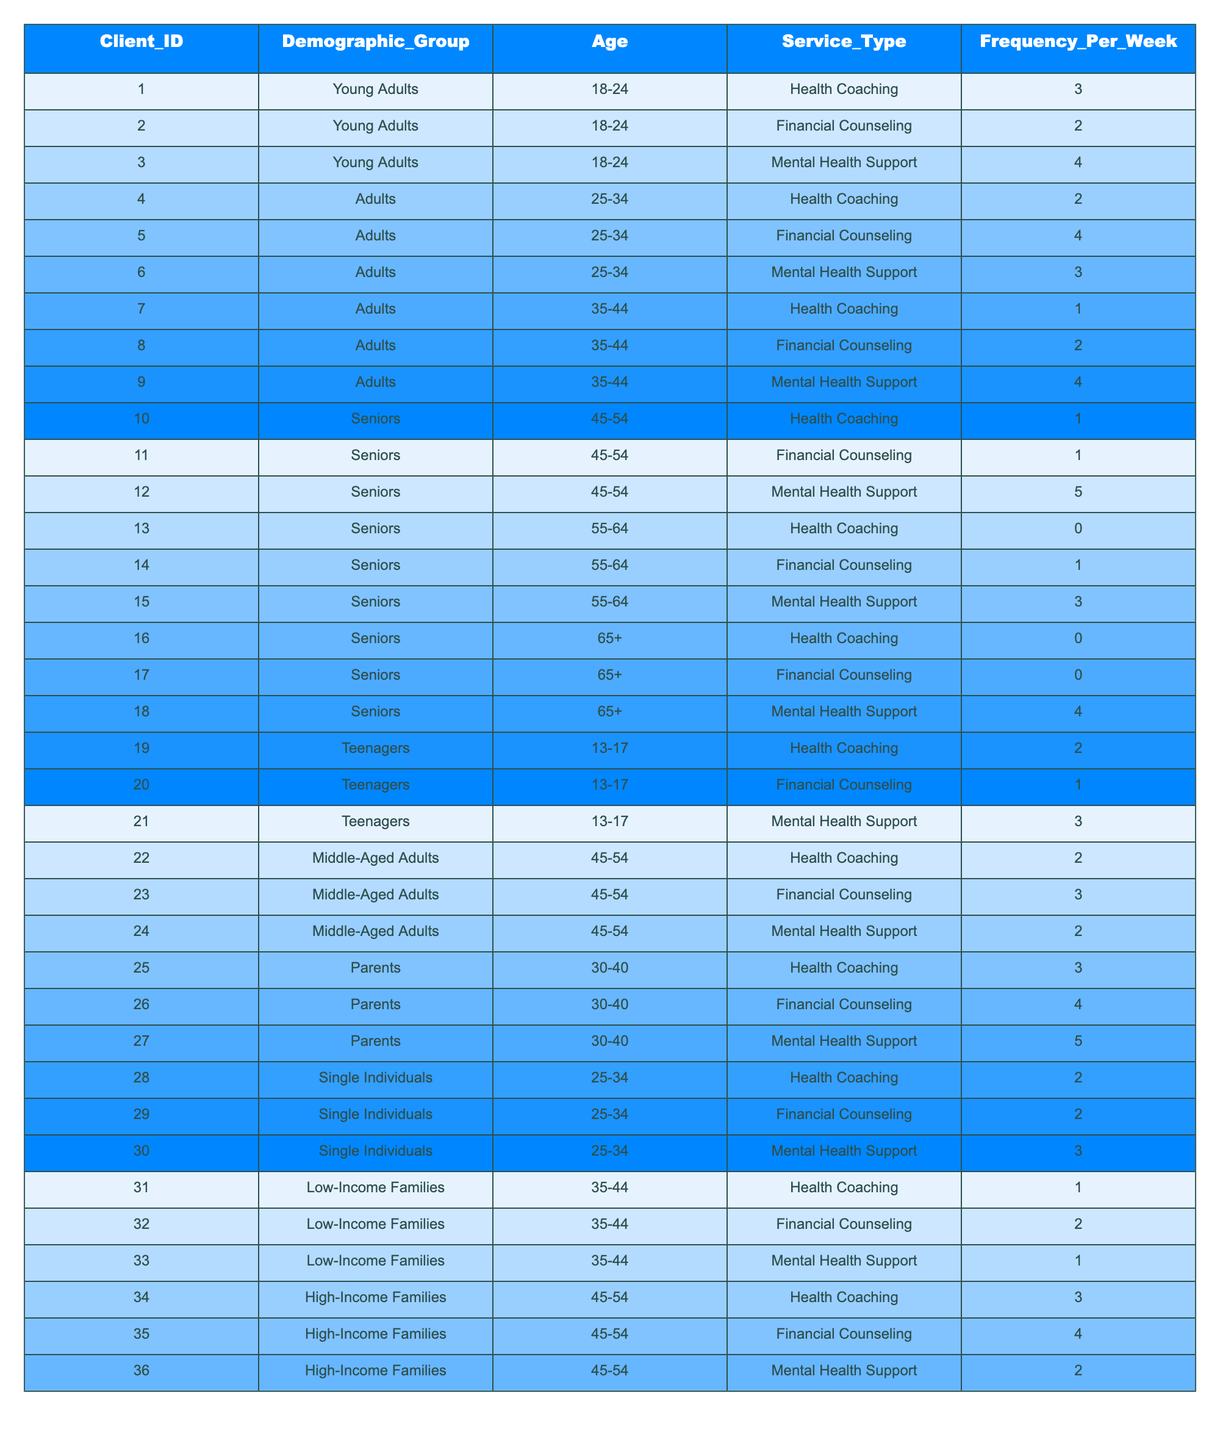What is the frequency of Mental Health Support among Young Adults? In the table, the frequency values for Mental Health Support among Young Adults (18-24) are found in the rows for Client IDs 3. The value is 4.
Answer: 4 Which demographic group has the highest average frequency of Financial Counseling? To determine this, we first sum the frequencies for Financial Counseling by demographic group. For Young Adults, it's 2; for Adults (25-34), it's 4; for Seniors (45-54), it's 1; for Middle-Aged Adults (45-54), it's 3; for Parents (30-40), it's 4; for Single Individuals (25-34), it's 2; for Low-Income Families (35-44), it's 2; and for High-Income Families (45-54), it's 4. The averages are then calculated, and the highest average is 4 for both Parents and High-Income Families.
Answer: Parents and High-Income Families Is there any demographic group that does not use Health Coaching? By checking the frequencies for Health Coaching across all demographic groups in the table, the values for Seniors in age ranges 55-64 and 65+ show 0 frequency. Therefore, both groups do not utilize Health Coaching.
Answer: Yes What is the total frequency of Service Usage for Seniors? The total frequency for Seniors can be calculated by summing the frequencies of all services they use: Health Coaching (1), Financial Counseling (1), Mental Health Support (5) = 1 + 1 + 5 = 7.
Answer: 7 Which group has the highest frequency for Mental Health Support and what is that frequency? To find the highest frequency for Mental Health Support, we look at each demographic group: Young Adults (4), Adults (35-44) (4), Seniors (45-54) (5), Seniors (55-64) (3), Seniors (65+) (4), Teenagers (3), Middle-Aged Adults (2), Parents (5), Single Individuals (3), Low-Income Families (1), High-Income Families (2). The maximum value is 5, which is from Seniors (45-54) and Parents (30-40).
Answer: Seniors (45-54) and Parents (30-40) with frequency of 5 How many different types of services do Low-Income Families use, and what is their total frequency? Low-Income Families utilize three types of services: Health Coaching (1), Financial Counseling (2), and Mental Health Support (1). Therefore, they use 3 different services, and the total frequency is 1 + 2 + 1 = 4.
Answer: Three services, total frequency 4 Is the frequency of Financial Counseling for Adults (25-34) higher than that for Teenagers (13-17)? For Adults (25-34), Financial Counseling frequency is 4. For Teenagers (13-17), it is 1. Since 4 is greater than 1, the frequency for Adults (25-34) is higher.
Answer: Yes What is the median frequency of Health Coaching across all demographic groups? First, we list the frequencies of Health Coaching: 3 (Young Adults), 2 (Adults 25-34), 1 (Adults 35-44), 1 (Seniors 45-54), 0 (Seniors 55-64), 0 (Seniors 65+), 2 (Teenagers 13-17), 2 (Middle-Aged Adults 45-54), 3 (Parents 30-40), 2 (Single Individuals 25-34), 1 (Low-Income Families 35-44), 3 (High-Income Families 45-54). The arranged values are: 0, 0, 1, 1, 2, 2, 2, 2, 3, 3, 3, 3. The median value (middle value) is the average of the 6th and 7th values (both are 2), thus the median frequency is 2.
Answer: 2 Which age group of Seniors has the highest usage of Mental Health Support? From the table, the frequencies of Mental Health Support for Seniors grouped by age are: 5 (45-54), 3 (55-64), and 4 (65+). The highest value is 5 for Seniors in the 45-54 age group.
Answer: Seniors (45-54) with frequency 5 What is the difference in frequency between Financial Counseling for High-Income Families and Parents? The frequency for Financial Counseling for High-Income Families is 4, while for Parents, it is also 4. The difference is calculated as 4 - 4 = 0.
Answer: 0 